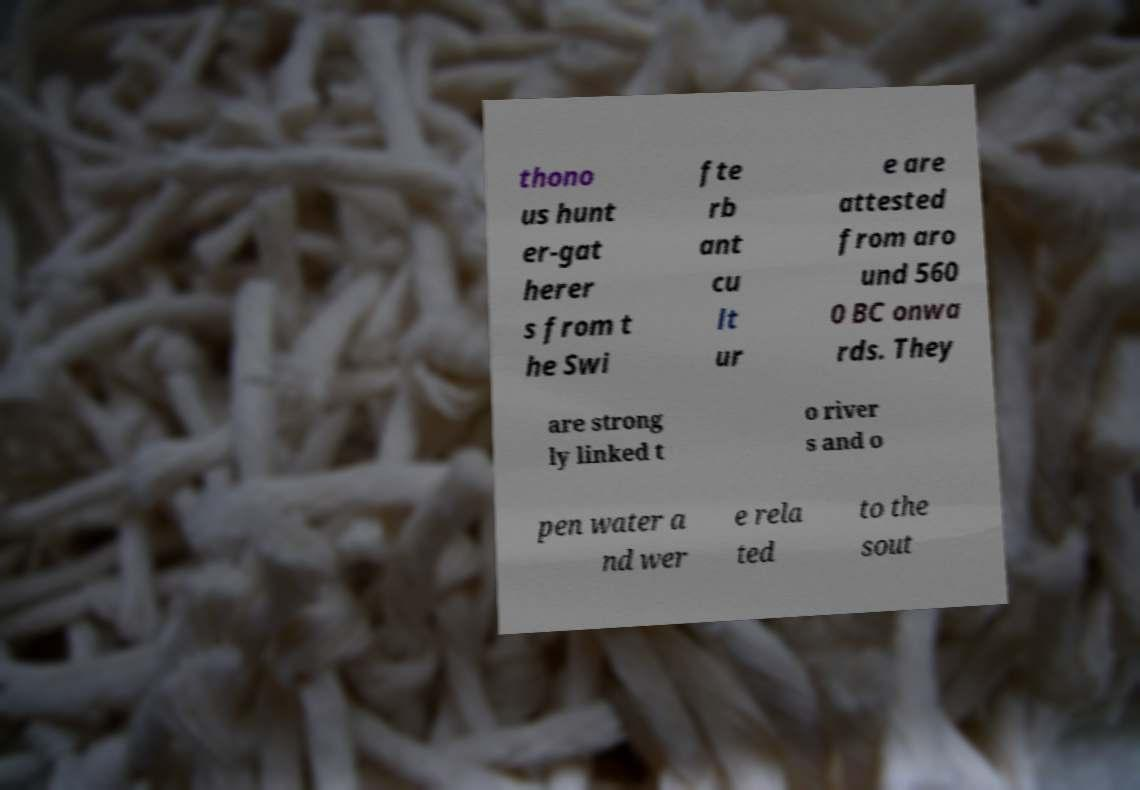There's text embedded in this image that I need extracted. Can you transcribe it verbatim? thono us hunt er-gat herer s from t he Swi fte rb ant cu lt ur e are attested from aro und 560 0 BC onwa rds. They are strong ly linked t o river s and o pen water a nd wer e rela ted to the sout 